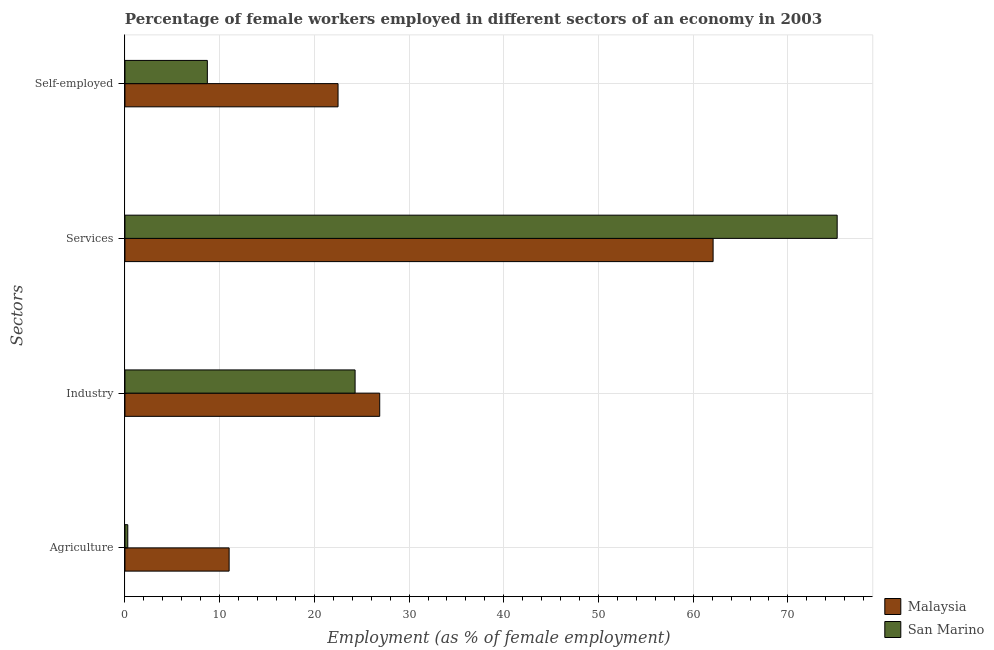How many bars are there on the 2nd tick from the top?
Ensure brevity in your answer.  2. What is the label of the 3rd group of bars from the top?
Your answer should be very brief. Industry. Across all countries, what is the minimum percentage of female workers in industry?
Offer a terse response. 24.3. In which country was the percentage of female workers in industry maximum?
Offer a terse response. Malaysia. In which country was the percentage of female workers in industry minimum?
Offer a terse response. San Marino. What is the total percentage of female workers in agriculture in the graph?
Provide a succinct answer. 11.3. What is the difference between the percentage of self employed female workers in Malaysia and that in San Marino?
Ensure brevity in your answer.  13.8. What is the difference between the percentage of female workers in agriculture in Malaysia and the percentage of female workers in industry in San Marino?
Offer a terse response. -13.3. What is the average percentage of female workers in services per country?
Your answer should be compact. 68.65. What is the difference between the percentage of female workers in services and percentage of self employed female workers in Malaysia?
Offer a terse response. 39.6. In how many countries, is the percentage of female workers in services greater than 60 %?
Keep it short and to the point. 2. What is the ratio of the percentage of female workers in services in Malaysia to that in San Marino?
Give a very brief answer. 0.83. What is the difference between the highest and the second highest percentage of female workers in services?
Offer a very short reply. 13.1. What is the difference between the highest and the lowest percentage of female workers in agriculture?
Make the answer very short. 10.7. What does the 1st bar from the top in Agriculture represents?
Provide a succinct answer. San Marino. What does the 1st bar from the bottom in Agriculture represents?
Make the answer very short. Malaysia. How many countries are there in the graph?
Give a very brief answer. 2. What is the difference between two consecutive major ticks on the X-axis?
Your answer should be compact. 10. Are the values on the major ticks of X-axis written in scientific E-notation?
Keep it short and to the point. No. Where does the legend appear in the graph?
Give a very brief answer. Bottom right. How many legend labels are there?
Offer a very short reply. 2. How are the legend labels stacked?
Your answer should be compact. Vertical. What is the title of the graph?
Offer a terse response. Percentage of female workers employed in different sectors of an economy in 2003. Does "Puerto Rico" appear as one of the legend labels in the graph?
Keep it short and to the point. No. What is the label or title of the X-axis?
Give a very brief answer. Employment (as % of female employment). What is the label or title of the Y-axis?
Your response must be concise. Sectors. What is the Employment (as % of female employment) in Malaysia in Agriculture?
Offer a very short reply. 11. What is the Employment (as % of female employment) in San Marino in Agriculture?
Give a very brief answer. 0.3. What is the Employment (as % of female employment) of Malaysia in Industry?
Ensure brevity in your answer.  26.9. What is the Employment (as % of female employment) in San Marino in Industry?
Give a very brief answer. 24.3. What is the Employment (as % of female employment) in Malaysia in Services?
Offer a very short reply. 62.1. What is the Employment (as % of female employment) of San Marino in Services?
Provide a short and direct response. 75.2. What is the Employment (as % of female employment) in San Marino in Self-employed?
Provide a short and direct response. 8.7. Across all Sectors, what is the maximum Employment (as % of female employment) in Malaysia?
Provide a succinct answer. 62.1. Across all Sectors, what is the maximum Employment (as % of female employment) of San Marino?
Your answer should be compact. 75.2. Across all Sectors, what is the minimum Employment (as % of female employment) of San Marino?
Your answer should be very brief. 0.3. What is the total Employment (as % of female employment) of Malaysia in the graph?
Offer a very short reply. 122.5. What is the total Employment (as % of female employment) of San Marino in the graph?
Your answer should be very brief. 108.5. What is the difference between the Employment (as % of female employment) in Malaysia in Agriculture and that in Industry?
Offer a very short reply. -15.9. What is the difference between the Employment (as % of female employment) of Malaysia in Agriculture and that in Services?
Your answer should be very brief. -51.1. What is the difference between the Employment (as % of female employment) of San Marino in Agriculture and that in Services?
Your response must be concise. -74.9. What is the difference between the Employment (as % of female employment) in San Marino in Agriculture and that in Self-employed?
Your response must be concise. -8.4. What is the difference between the Employment (as % of female employment) of Malaysia in Industry and that in Services?
Provide a short and direct response. -35.2. What is the difference between the Employment (as % of female employment) in San Marino in Industry and that in Services?
Offer a very short reply. -50.9. What is the difference between the Employment (as % of female employment) of Malaysia in Industry and that in Self-employed?
Provide a short and direct response. 4.4. What is the difference between the Employment (as % of female employment) in Malaysia in Services and that in Self-employed?
Give a very brief answer. 39.6. What is the difference between the Employment (as % of female employment) in San Marino in Services and that in Self-employed?
Offer a terse response. 66.5. What is the difference between the Employment (as % of female employment) in Malaysia in Agriculture and the Employment (as % of female employment) in San Marino in Services?
Ensure brevity in your answer.  -64.2. What is the difference between the Employment (as % of female employment) in Malaysia in Agriculture and the Employment (as % of female employment) in San Marino in Self-employed?
Give a very brief answer. 2.3. What is the difference between the Employment (as % of female employment) in Malaysia in Industry and the Employment (as % of female employment) in San Marino in Services?
Your answer should be compact. -48.3. What is the difference between the Employment (as % of female employment) of Malaysia in Industry and the Employment (as % of female employment) of San Marino in Self-employed?
Provide a succinct answer. 18.2. What is the difference between the Employment (as % of female employment) in Malaysia in Services and the Employment (as % of female employment) in San Marino in Self-employed?
Give a very brief answer. 53.4. What is the average Employment (as % of female employment) in Malaysia per Sectors?
Give a very brief answer. 30.62. What is the average Employment (as % of female employment) in San Marino per Sectors?
Offer a terse response. 27.12. What is the difference between the Employment (as % of female employment) in Malaysia and Employment (as % of female employment) in San Marino in Agriculture?
Provide a succinct answer. 10.7. What is the ratio of the Employment (as % of female employment) in Malaysia in Agriculture to that in Industry?
Provide a succinct answer. 0.41. What is the ratio of the Employment (as % of female employment) of San Marino in Agriculture to that in Industry?
Offer a very short reply. 0.01. What is the ratio of the Employment (as % of female employment) in Malaysia in Agriculture to that in Services?
Give a very brief answer. 0.18. What is the ratio of the Employment (as % of female employment) in San Marino in Agriculture to that in Services?
Offer a very short reply. 0. What is the ratio of the Employment (as % of female employment) in Malaysia in Agriculture to that in Self-employed?
Provide a short and direct response. 0.49. What is the ratio of the Employment (as % of female employment) of San Marino in Agriculture to that in Self-employed?
Give a very brief answer. 0.03. What is the ratio of the Employment (as % of female employment) in Malaysia in Industry to that in Services?
Give a very brief answer. 0.43. What is the ratio of the Employment (as % of female employment) of San Marino in Industry to that in Services?
Make the answer very short. 0.32. What is the ratio of the Employment (as % of female employment) of Malaysia in Industry to that in Self-employed?
Make the answer very short. 1.2. What is the ratio of the Employment (as % of female employment) in San Marino in Industry to that in Self-employed?
Offer a terse response. 2.79. What is the ratio of the Employment (as % of female employment) in Malaysia in Services to that in Self-employed?
Provide a short and direct response. 2.76. What is the ratio of the Employment (as % of female employment) of San Marino in Services to that in Self-employed?
Provide a succinct answer. 8.64. What is the difference between the highest and the second highest Employment (as % of female employment) of Malaysia?
Your response must be concise. 35.2. What is the difference between the highest and the second highest Employment (as % of female employment) of San Marino?
Your answer should be compact. 50.9. What is the difference between the highest and the lowest Employment (as % of female employment) in Malaysia?
Give a very brief answer. 51.1. What is the difference between the highest and the lowest Employment (as % of female employment) of San Marino?
Your response must be concise. 74.9. 